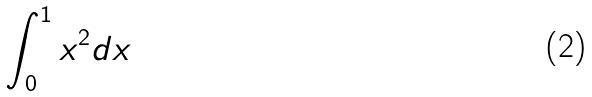Convert formula to latex. <formula><loc_0><loc_0><loc_500><loc_500>\int _ { 0 } ^ { 1 } x ^ { 2 } d x</formula> 